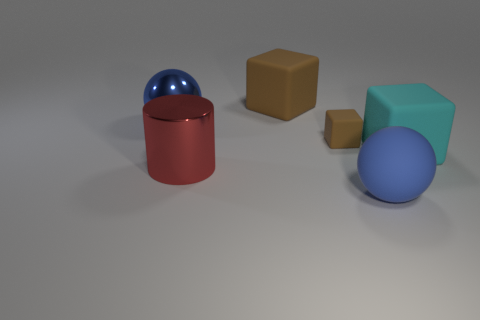Subtract all brown cubes. How many cubes are left? 1 Subtract all brown matte blocks. How many blocks are left? 1 Add 2 small yellow metal spheres. How many objects exist? 8 Subtract 2 blocks. How many blocks are left? 1 Subtract all green balls. Subtract all purple cylinders. How many balls are left? 2 Subtract all green cylinders. How many yellow blocks are left? 0 Add 5 small rubber things. How many small rubber things exist? 6 Subtract 0 gray balls. How many objects are left? 6 Subtract all balls. How many objects are left? 4 Subtract all gray objects. Subtract all tiny rubber blocks. How many objects are left? 5 